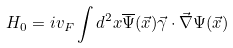Convert formula to latex. <formula><loc_0><loc_0><loc_500><loc_500>H _ { 0 } & = i v _ { F } \int d ^ { 2 } x \overline { \Psi } ( \vec { x } ) \vec { \gamma } \cdot \vec { \nabla } \Psi ( \vec { x } )</formula> 